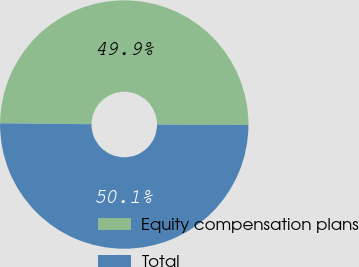<chart> <loc_0><loc_0><loc_500><loc_500><pie_chart><fcel>Equity compensation plans<fcel>Total<nl><fcel>49.9%<fcel>50.1%<nl></chart> 